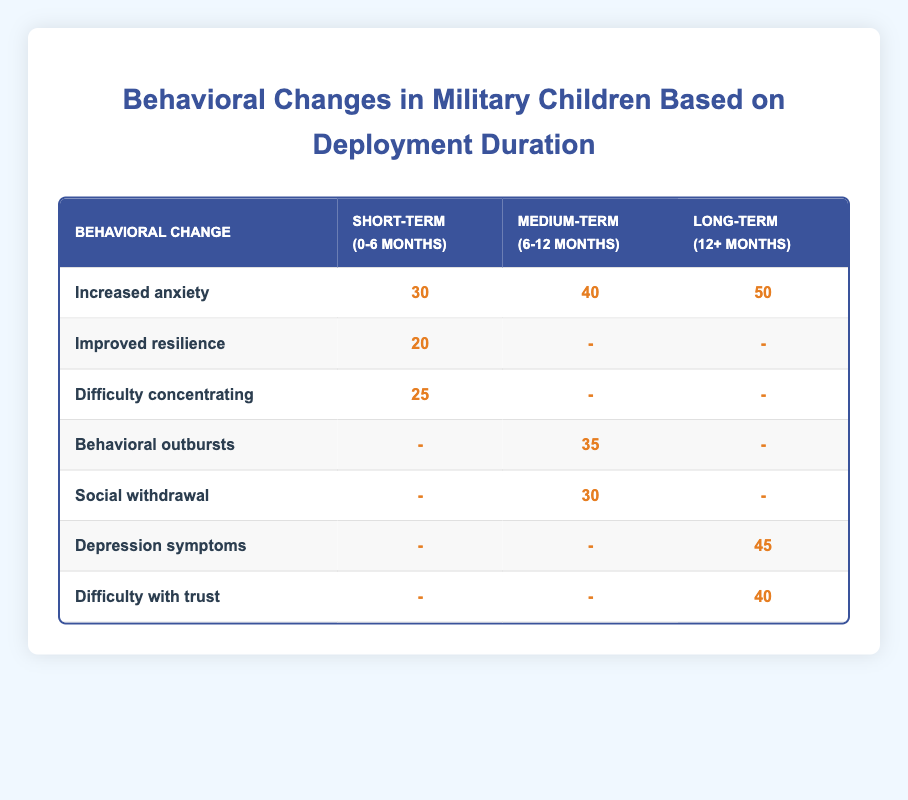What is the number of children with increased anxiety during Long-term deployment (12+ months)? The table shows that under the long-term deployment duration, 50 children reported increased anxiety.
Answer: 50 How many children showed improved resilience during Short-term deployment (0-6 months)? The table indicates that 20 children reported improved resilience in the short-term deployment category.
Answer: 20 What is the total number of children that experienced behavioral outbursts during Medium-term deployment (6-12 months)? The total number of children that experienced behavioral outbursts is directly stated in the table as 35.
Answer: 35 Which behavioral change had the highest number of children reporting it? By comparing the values in the table, the behavioral change 'Increased anxiety' during Long-term deployment recorded the highest number at 50 children.
Answer: Increased anxiety How many total children experienced difficulty concentrating across all deployment durations? In short-term deployment, 25 children had difficulty concentrating. There are no children reported for this issue in medium and long-term deployments, so the total is 25.
Answer: 25 Is there any behavioral change reported during the Medium-term deployment in the table? Yes, behavioral outbursts and social withdrawal are both reported in the medium-term deployment category, indicating that there are behavioral changes associated with this duration.
Answer: Yes What is the difference in the number of children reporting increased anxiety between Long-term and Medium-term deployments? The table shows 50 children for Long-term and 40 for Medium-term. The difference can be calculated as 50 - 40 = 10.
Answer: 10 How many children reported depression symptoms over the Long-term deployment? The table states that 45 children reported depression symptoms under the long-term deployment category.
Answer: 45 What percentage of children experienced increased anxiety compared to the total number reporting any behavioral changes across all deployment durations? The total number experiencing increased anxiety across all durations is 30 (short-term) + 40 (medium-term) + 50 (long-term) = 120. The percentage of children with increased anxiety is (30 + 40 + 50) / (30 + 20 + 25 + 40 + 35 + 30 + 50 + 45 + 40) = 120 / 320 = 0.375, or 37.5%.
Answer: 37.5% 